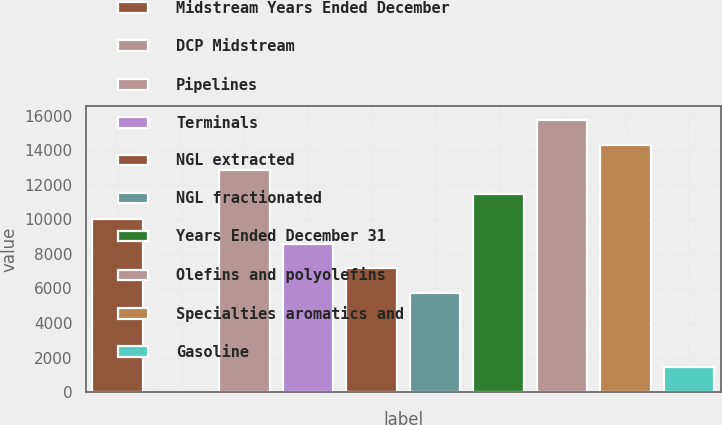<chart> <loc_0><loc_0><loc_500><loc_500><bar_chart><fcel>Midstream Years Ended December<fcel>DCP Midstream<fcel>Pipelines<fcel>Terminals<fcel>NGL extracted<fcel>NGL fractionated<fcel>Years Ended December 31<fcel>Olefins and polyolefins<fcel>Specialties aromatics and<fcel>Gasoline<nl><fcel>10013.9<fcel>1.21<fcel>12874.6<fcel>8583.49<fcel>7153.11<fcel>5722.73<fcel>11444.2<fcel>15735.4<fcel>14305<fcel>1431.59<nl></chart> 